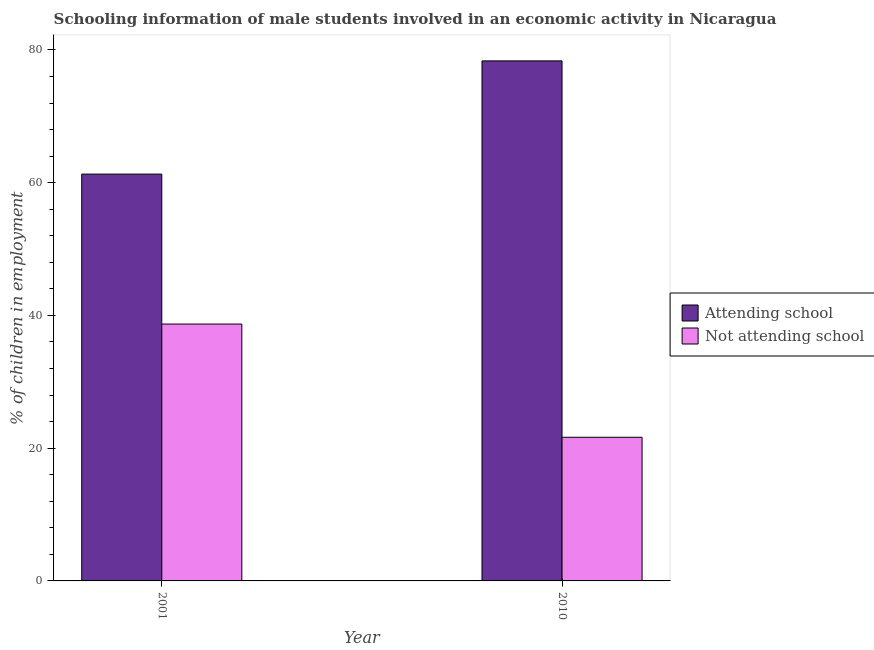How many different coloured bars are there?
Offer a terse response. 2. How many groups of bars are there?
Your answer should be compact. 2. Are the number of bars per tick equal to the number of legend labels?
Your response must be concise. Yes. How many bars are there on the 1st tick from the left?
Make the answer very short. 2. How many bars are there on the 2nd tick from the right?
Ensure brevity in your answer.  2. What is the label of the 1st group of bars from the left?
Provide a short and direct response. 2001. What is the percentage of employed males who are not attending school in 2010?
Ensure brevity in your answer.  21.64. Across all years, what is the maximum percentage of employed males who are not attending school?
Your answer should be very brief. 38.7. Across all years, what is the minimum percentage of employed males who are attending school?
Make the answer very short. 61.3. What is the total percentage of employed males who are not attending school in the graph?
Give a very brief answer. 60.35. What is the difference between the percentage of employed males who are not attending school in 2001 and that in 2010?
Give a very brief answer. 17.06. What is the difference between the percentage of employed males who are not attending school in 2001 and the percentage of employed males who are attending school in 2010?
Ensure brevity in your answer.  17.06. What is the average percentage of employed males who are not attending school per year?
Your answer should be very brief. 30.17. What is the ratio of the percentage of employed males who are attending school in 2001 to that in 2010?
Your answer should be very brief. 0.78. What does the 2nd bar from the left in 2010 represents?
Your response must be concise. Not attending school. What does the 1st bar from the right in 2010 represents?
Ensure brevity in your answer.  Not attending school. Are all the bars in the graph horizontal?
Ensure brevity in your answer.  No. How many legend labels are there?
Provide a succinct answer. 2. How are the legend labels stacked?
Your answer should be compact. Vertical. What is the title of the graph?
Give a very brief answer. Schooling information of male students involved in an economic activity in Nicaragua. Does "Private credit bureau" appear as one of the legend labels in the graph?
Make the answer very short. No. What is the label or title of the Y-axis?
Keep it short and to the point. % of children in employment. What is the % of children in employment of Attending school in 2001?
Offer a very short reply. 61.3. What is the % of children in employment in Not attending school in 2001?
Offer a very short reply. 38.7. What is the % of children in employment of Attending school in 2010?
Ensure brevity in your answer.  78.36. What is the % of children in employment of Not attending school in 2010?
Provide a succinct answer. 21.64. Across all years, what is the maximum % of children in employment of Attending school?
Your answer should be compact. 78.36. Across all years, what is the maximum % of children in employment of Not attending school?
Give a very brief answer. 38.7. Across all years, what is the minimum % of children in employment of Attending school?
Keep it short and to the point. 61.3. Across all years, what is the minimum % of children in employment of Not attending school?
Ensure brevity in your answer.  21.64. What is the total % of children in employment of Attending school in the graph?
Provide a short and direct response. 139.65. What is the total % of children in employment of Not attending school in the graph?
Your answer should be very brief. 60.35. What is the difference between the % of children in employment in Attending school in 2001 and that in 2010?
Provide a succinct answer. -17.06. What is the difference between the % of children in employment of Not attending school in 2001 and that in 2010?
Your answer should be compact. 17.06. What is the difference between the % of children in employment of Attending school in 2001 and the % of children in employment of Not attending school in 2010?
Ensure brevity in your answer.  39.65. What is the average % of children in employment in Attending school per year?
Offer a very short reply. 69.83. What is the average % of children in employment in Not attending school per year?
Give a very brief answer. 30.17. In the year 2001, what is the difference between the % of children in employment in Attending school and % of children in employment in Not attending school?
Your answer should be compact. 22.59. In the year 2010, what is the difference between the % of children in employment in Attending school and % of children in employment in Not attending school?
Ensure brevity in your answer.  56.71. What is the ratio of the % of children in employment of Attending school in 2001 to that in 2010?
Give a very brief answer. 0.78. What is the ratio of the % of children in employment of Not attending school in 2001 to that in 2010?
Make the answer very short. 1.79. What is the difference between the highest and the second highest % of children in employment in Attending school?
Keep it short and to the point. 17.06. What is the difference between the highest and the second highest % of children in employment of Not attending school?
Your answer should be very brief. 17.06. What is the difference between the highest and the lowest % of children in employment of Attending school?
Offer a terse response. 17.06. What is the difference between the highest and the lowest % of children in employment in Not attending school?
Keep it short and to the point. 17.06. 